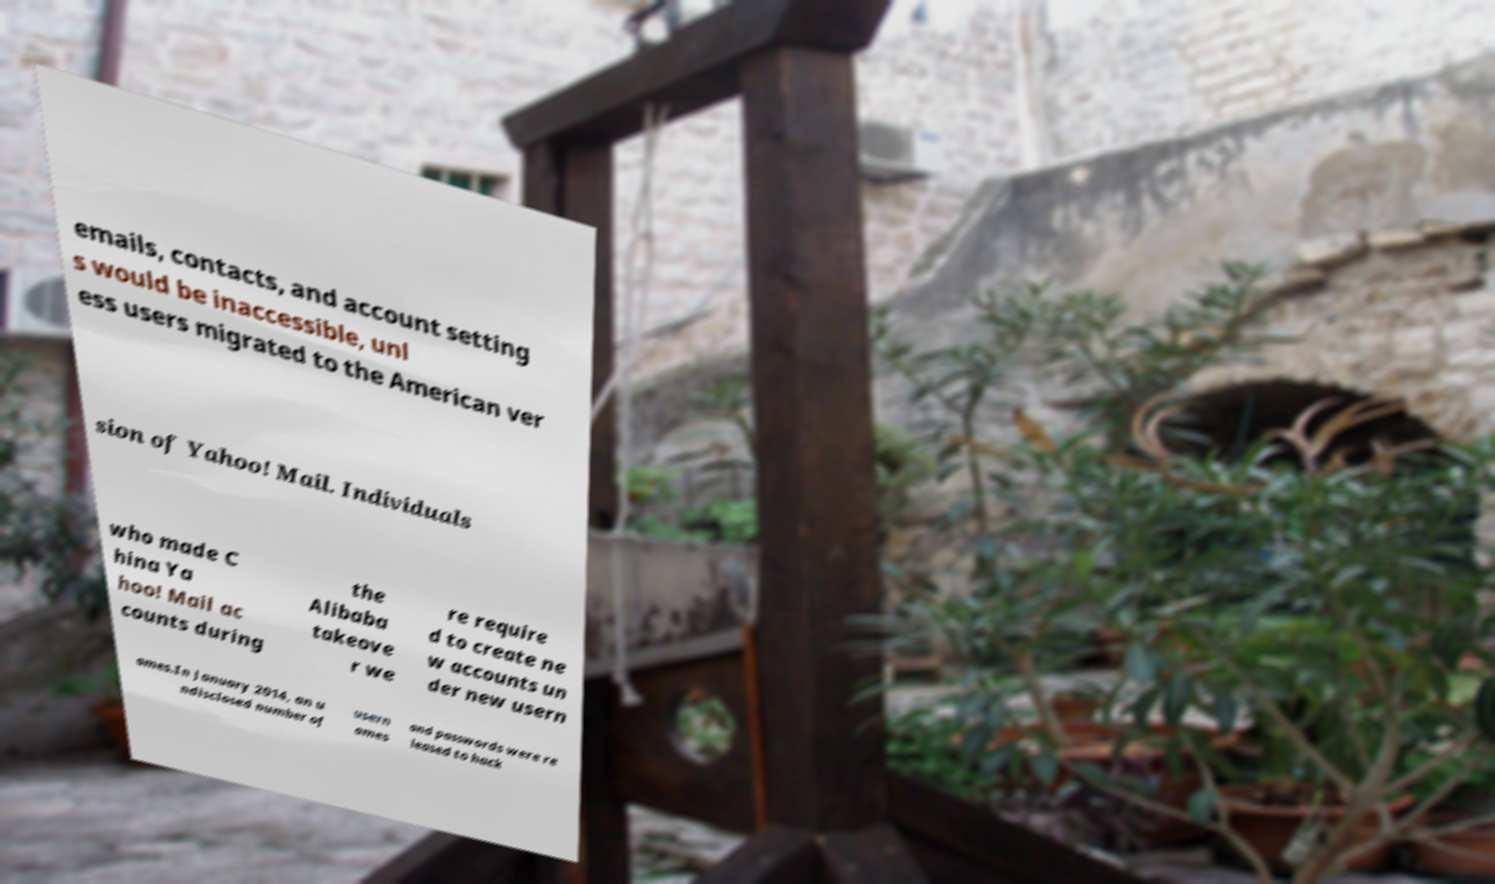For documentation purposes, I need the text within this image transcribed. Could you provide that? emails, contacts, and account setting s would be inaccessible, unl ess users migrated to the American ver sion of Yahoo! Mail. Individuals who made C hina Ya hoo! Mail ac counts during the Alibaba takeove r we re require d to create ne w accounts un der new usern ames.In January 2014, an u ndisclosed number of usern ames and passwords were re leased to hack 